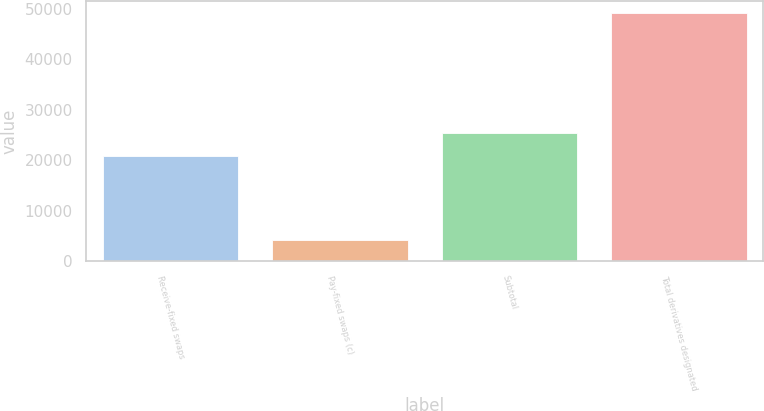<chart> <loc_0><loc_0><loc_500><loc_500><bar_chart><fcel>Receive-fixed swaps<fcel>Pay-fixed swaps (c)<fcel>Subtotal<fcel>Total derivatives designated<nl><fcel>20930<fcel>4233<fcel>25412.8<fcel>49061<nl></chart> 